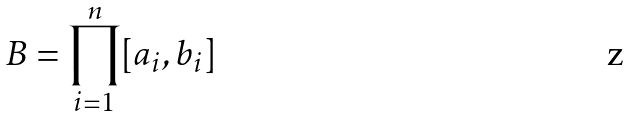Convert formula to latex. <formula><loc_0><loc_0><loc_500><loc_500>B = \prod _ { i = 1 } ^ { n } [ a _ { i } , b _ { i } ]</formula> 